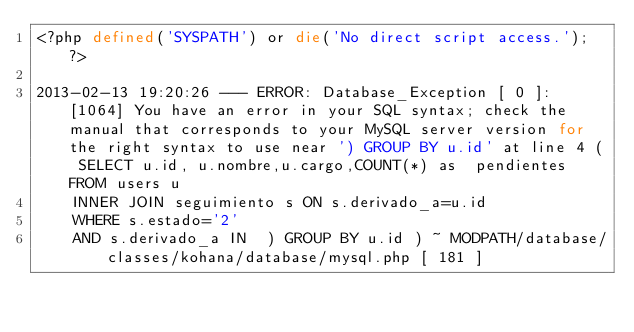<code> <loc_0><loc_0><loc_500><loc_500><_PHP_><?php defined('SYSPATH') or die('No direct script access.'); ?>

2013-02-13 19:20:26 --- ERROR: Database_Exception [ 0 ]: [1064] You have an error in your SQL syntax; check the manual that corresponds to your MySQL server version for the right syntax to use near ') GROUP BY u.id' at line 4 ( SELECT u.id, u.nombre,u.cargo,COUNT(*) as  pendientes FROM users u
    INNER JOIN seguimiento s ON s.derivado_a=u.id
    WHERE s.estado='2'
    AND s.derivado_a IN  ) GROUP BY u.id ) ~ MODPATH/database/classes/kohana/database/mysql.php [ 181 ]</code> 